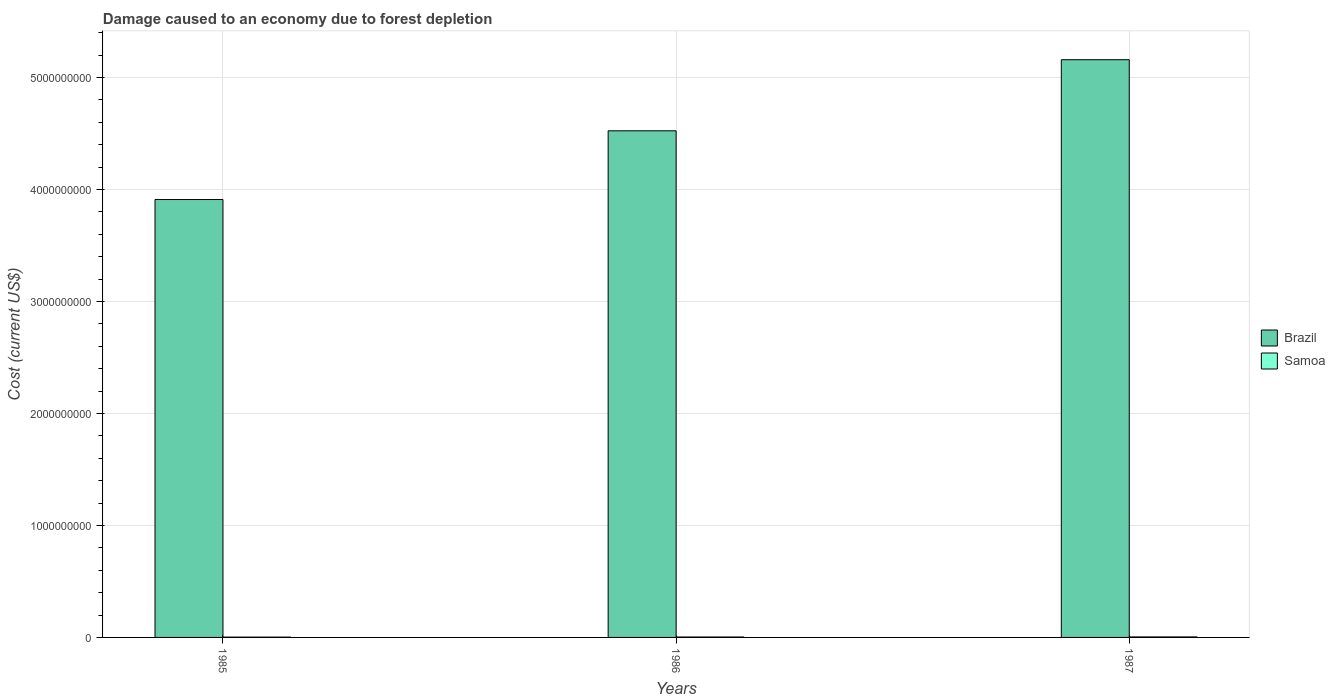How many different coloured bars are there?
Your answer should be compact. 2. How many groups of bars are there?
Make the answer very short. 3. Are the number of bars per tick equal to the number of legend labels?
Provide a short and direct response. Yes. How many bars are there on the 1st tick from the left?
Your answer should be very brief. 2. In how many cases, is the number of bars for a given year not equal to the number of legend labels?
Make the answer very short. 0. What is the cost of damage caused due to forest depletion in Samoa in 1987?
Provide a succinct answer. 4.40e+06. Across all years, what is the maximum cost of damage caused due to forest depletion in Samoa?
Make the answer very short. 4.40e+06. Across all years, what is the minimum cost of damage caused due to forest depletion in Samoa?
Your answer should be very brief. 2.59e+06. In which year was the cost of damage caused due to forest depletion in Samoa maximum?
Offer a very short reply. 1987. What is the total cost of damage caused due to forest depletion in Brazil in the graph?
Your answer should be very brief. 1.36e+1. What is the difference between the cost of damage caused due to forest depletion in Brazil in 1985 and that in 1986?
Offer a very short reply. -6.14e+08. What is the difference between the cost of damage caused due to forest depletion in Samoa in 1987 and the cost of damage caused due to forest depletion in Brazil in 1985?
Offer a terse response. -3.91e+09. What is the average cost of damage caused due to forest depletion in Brazil per year?
Make the answer very short. 4.53e+09. In the year 1986, what is the difference between the cost of damage caused due to forest depletion in Brazil and cost of damage caused due to forest depletion in Samoa?
Provide a succinct answer. 4.52e+09. What is the ratio of the cost of damage caused due to forest depletion in Samoa in 1985 to that in 1987?
Provide a short and direct response. 0.59. Is the cost of damage caused due to forest depletion in Samoa in 1985 less than that in 1986?
Offer a terse response. Yes. Is the difference between the cost of damage caused due to forest depletion in Brazil in 1986 and 1987 greater than the difference between the cost of damage caused due to forest depletion in Samoa in 1986 and 1987?
Provide a short and direct response. No. What is the difference between the highest and the second highest cost of damage caused due to forest depletion in Brazil?
Your answer should be very brief. 6.35e+08. What is the difference between the highest and the lowest cost of damage caused due to forest depletion in Samoa?
Give a very brief answer. 1.81e+06. In how many years, is the cost of damage caused due to forest depletion in Brazil greater than the average cost of damage caused due to forest depletion in Brazil taken over all years?
Ensure brevity in your answer.  1. What does the 2nd bar from the left in 1986 represents?
Offer a very short reply. Samoa. What does the 1st bar from the right in 1985 represents?
Provide a short and direct response. Samoa. What is the difference between two consecutive major ticks on the Y-axis?
Give a very brief answer. 1.00e+09. Are the values on the major ticks of Y-axis written in scientific E-notation?
Your answer should be very brief. No. How are the legend labels stacked?
Offer a terse response. Vertical. What is the title of the graph?
Keep it short and to the point. Damage caused to an economy due to forest depletion. What is the label or title of the X-axis?
Provide a succinct answer. Years. What is the label or title of the Y-axis?
Give a very brief answer. Cost (current US$). What is the Cost (current US$) of Brazil in 1985?
Give a very brief answer. 3.91e+09. What is the Cost (current US$) in Samoa in 1985?
Ensure brevity in your answer.  2.59e+06. What is the Cost (current US$) in Brazil in 1986?
Ensure brevity in your answer.  4.52e+09. What is the Cost (current US$) in Samoa in 1986?
Your answer should be compact. 3.61e+06. What is the Cost (current US$) in Brazil in 1987?
Give a very brief answer. 5.16e+09. What is the Cost (current US$) in Samoa in 1987?
Offer a terse response. 4.40e+06. Across all years, what is the maximum Cost (current US$) in Brazil?
Provide a short and direct response. 5.16e+09. Across all years, what is the maximum Cost (current US$) of Samoa?
Provide a succinct answer. 4.40e+06. Across all years, what is the minimum Cost (current US$) of Brazil?
Ensure brevity in your answer.  3.91e+09. Across all years, what is the minimum Cost (current US$) of Samoa?
Ensure brevity in your answer.  2.59e+06. What is the total Cost (current US$) of Brazil in the graph?
Your answer should be compact. 1.36e+1. What is the total Cost (current US$) in Samoa in the graph?
Your answer should be very brief. 1.06e+07. What is the difference between the Cost (current US$) of Brazil in 1985 and that in 1986?
Your answer should be compact. -6.14e+08. What is the difference between the Cost (current US$) of Samoa in 1985 and that in 1986?
Your response must be concise. -1.01e+06. What is the difference between the Cost (current US$) of Brazil in 1985 and that in 1987?
Provide a short and direct response. -1.25e+09. What is the difference between the Cost (current US$) of Samoa in 1985 and that in 1987?
Make the answer very short. -1.81e+06. What is the difference between the Cost (current US$) of Brazil in 1986 and that in 1987?
Keep it short and to the point. -6.35e+08. What is the difference between the Cost (current US$) in Samoa in 1986 and that in 1987?
Give a very brief answer. -7.96e+05. What is the difference between the Cost (current US$) of Brazil in 1985 and the Cost (current US$) of Samoa in 1986?
Provide a succinct answer. 3.91e+09. What is the difference between the Cost (current US$) in Brazil in 1985 and the Cost (current US$) in Samoa in 1987?
Keep it short and to the point. 3.91e+09. What is the difference between the Cost (current US$) of Brazil in 1986 and the Cost (current US$) of Samoa in 1987?
Ensure brevity in your answer.  4.52e+09. What is the average Cost (current US$) in Brazil per year?
Your response must be concise. 4.53e+09. What is the average Cost (current US$) of Samoa per year?
Provide a short and direct response. 3.53e+06. In the year 1985, what is the difference between the Cost (current US$) of Brazil and Cost (current US$) of Samoa?
Offer a terse response. 3.91e+09. In the year 1986, what is the difference between the Cost (current US$) of Brazil and Cost (current US$) of Samoa?
Keep it short and to the point. 4.52e+09. In the year 1987, what is the difference between the Cost (current US$) in Brazil and Cost (current US$) in Samoa?
Your answer should be compact. 5.15e+09. What is the ratio of the Cost (current US$) in Brazil in 1985 to that in 1986?
Give a very brief answer. 0.86. What is the ratio of the Cost (current US$) of Samoa in 1985 to that in 1986?
Offer a terse response. 0.72. What is the ratio of the Cost (current US$) of Brazil in 1985 to that in 1987?
Give a very brief answer. 0.76. What is the ratio of the Cost (current US$) of Samoa in 1985 to that in 1987?
Your answer should be very brief. 0.59. What is the ratio of the Cost (current US$) in Brazil in 1986 to that in 1987?
Give a very brief answer. 0.88. What is the ratio of the Cost (current US$) in Samoa in 1986 to that in 1987?
Give a very brief answer. 0.82. What is the difference between the highest and the second highest Cost (current US$) in Brazil?
Offer a terse response. 6.35e+08. What is the difference between the highest and the second highest Cost (current US$) of Samoa?
Your answer should be compact. 7.96e+05. What is the difference between the highest and the lowest Cost (current US$) in Brazil?
Give a very brief answer. 1.25e+09. What is the difference between the highest and the lowest Cost (current US$) in Samoa?
Your answer should be compact. 1.81e+06. 